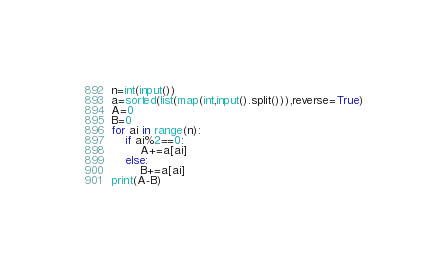<code> <loc_0><loc_0><loc_500><loc_500><_Python_>n=int(input())
a=sorted(list(map(int,input().split())),reverse=True)
A=0
B=0
for ai in range(n):
	if ai%2==0:
		A+=a[ai]
	else:
		B+=a[ai]
print(A-B)</code> 